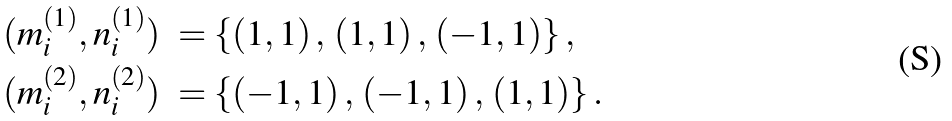<formula> <loc_0><loc_0><loc_500><loc_500>& ( m _ { i } ^ { ( 1 ) } , n _ { i } ^ { ( 1 ) } ) \ = \{ ( 1 , 1 ) \, , \, ( 1 , 1 ) \, , \, ( - 1 , 1 ) \} \, , \\ & ( m _ { i } ^ { ( 2 ) } , n _ { i } ^ { ( 2 ) } ) \ = \{ ( - 1 , 1 ) \, , \, ( - 1 , 1 ) \, , \, ( 1 , 1 ) \} \, . \\</formula> 